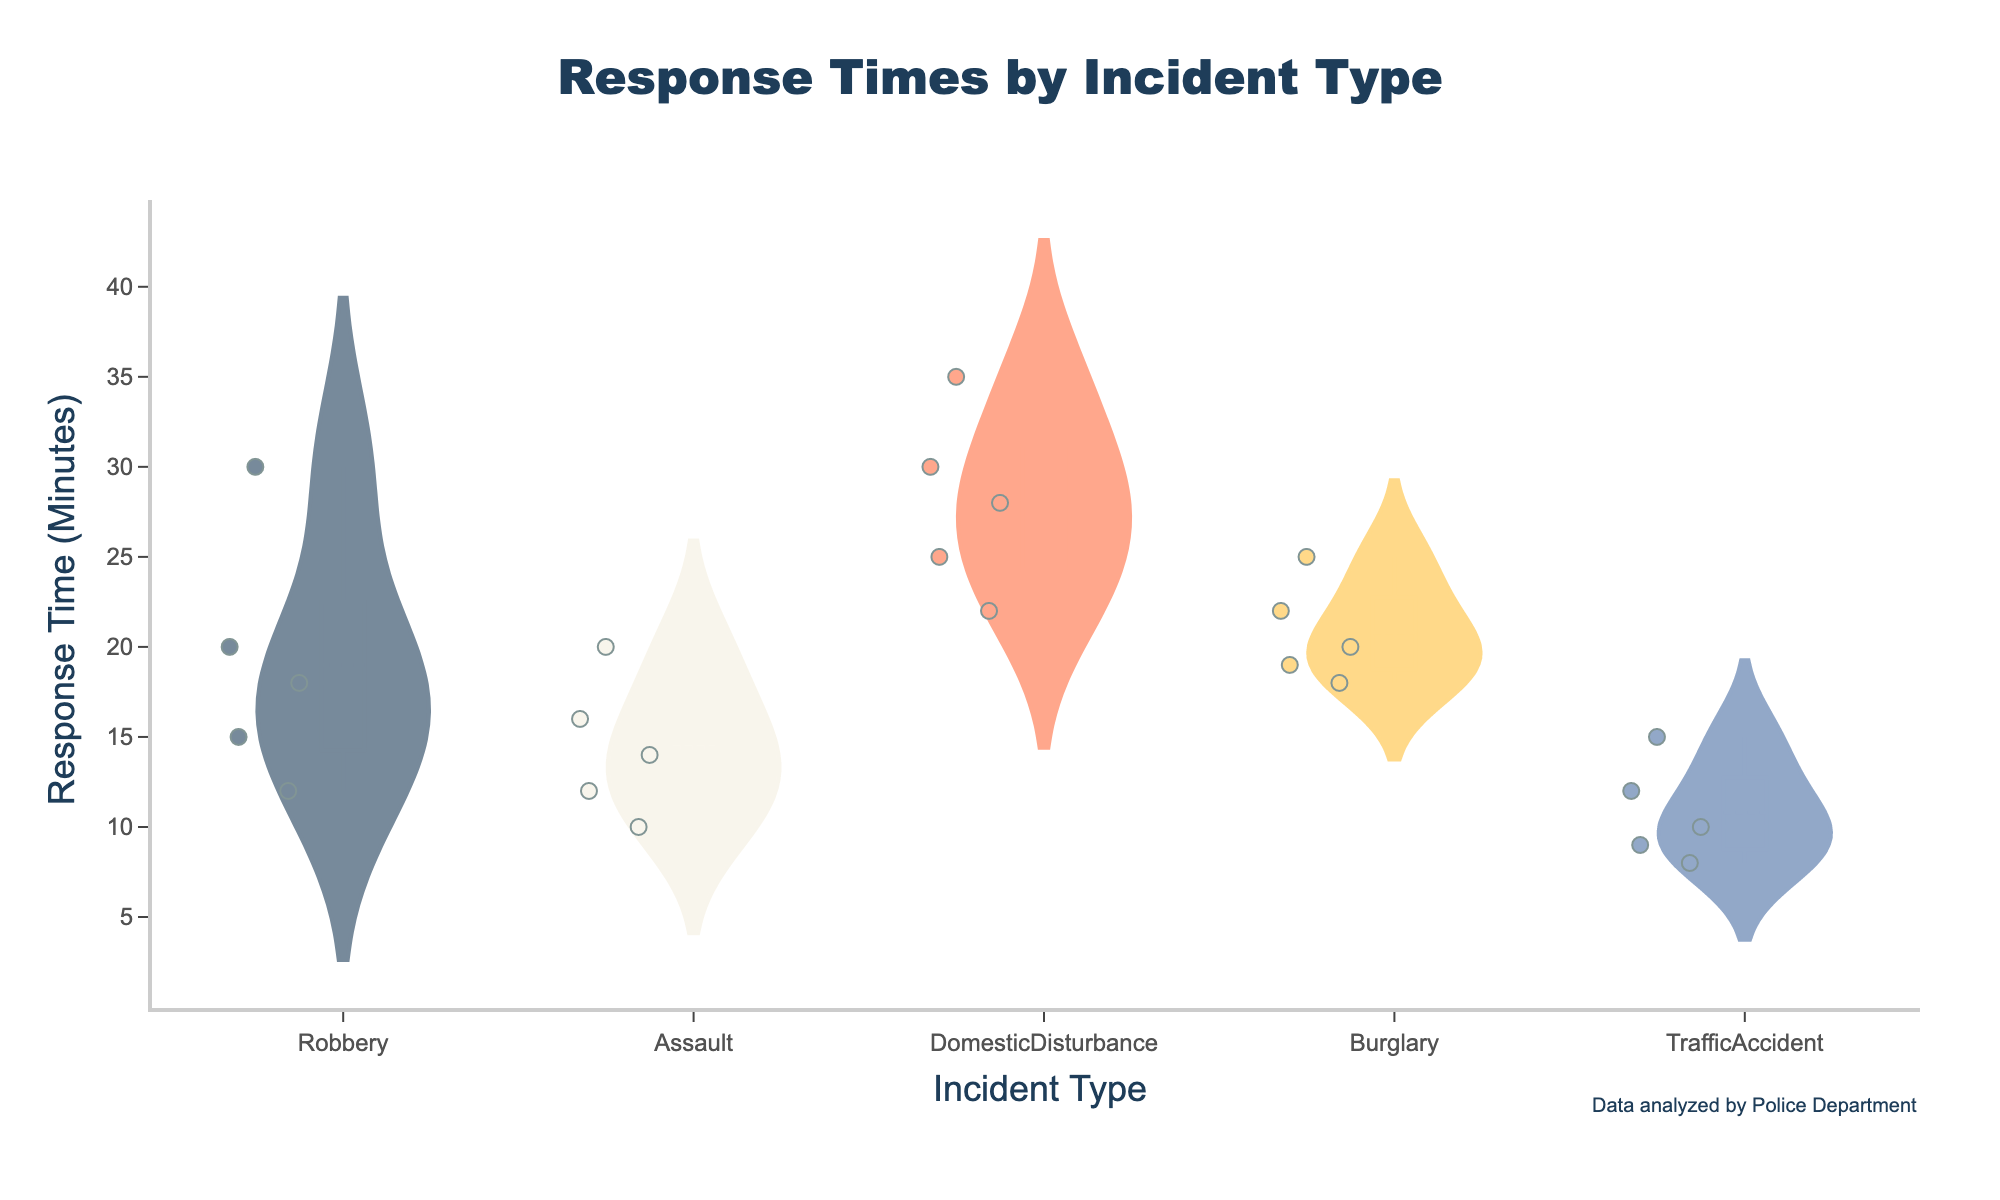What's the title of the figure? The title of the figure is displayed at the top center of the plot. It summarizes the content of the figure in a few words.
Answer: Response Times by Incident Type What are the incident types displayed on the x-axis? The x-axis contains the categories of incidents that the data was segmented into.
Answer: Robbery, Assault, Domestic Disturbance, Burglary, Traffic Accident Which incident type has the shortest average response time? By examining the mean lines on each violin plot, the one with the lowest mean line represents the shortest average response time.
Answer: Traffic Accident Which incident type shows the widest range of response times? The widest range of response times can be identified by observing the spread or length of the violin plots.
Answer: Domestic Disturbance How many data points are there for the 'Robbery' incident type? Each dot in the violin plot represents a data point, and we can count these for the 'Robbery' category.
Answer: 5 Compare the median response times for Robbery and Assault. Which is greater? The medians are shown by the lines in the center of the box plots within each violin plot. Compare these lines for both Robbery and Assault.
Answer: Robbery What’s the interquartile range (IQR) for Domestic Disturbance? The IQR can be identified by the length of the box plot within the violin plot. It spans from the first quartile (Q1, bottom of the box) to the third quartile (Q3, top of the box).
Answer: 8 minutes Which incident type has the highest variability in response times? This can be determined by comparing the overall shapes and sizes of the violin plots, with particular attention to the range covered by the data points.
Answer: Domestic Disturbance Are there any outliers in the response times for 'Burglary'? Outliers are usually represented by points outside the range of the whiskers in the box plot.
Answer: No Between 'Assault' and 'Traffic Accident', which category has a tighter distribution of response times? The tighter distribution can be observed by looking at how narrow the violin plot and the box plot are for each category.
Answer: Traffic Accident 